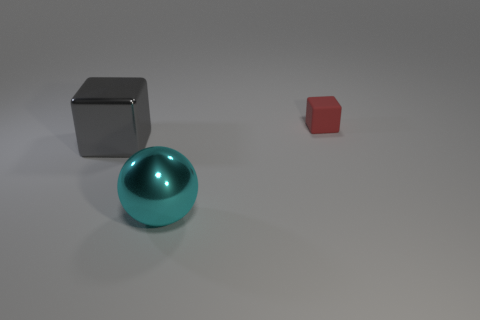Is there anything else that has the same shape as the cyan metal thing?
Provide a succinct answer. No. The other gray metal thing that is the same shape as the tiny object is what size?
Give a very brief answer. Large. Is there any other thing that is the same size as the red thing?
Keep it short and to the point. No. There is a big shiny sphere; are there any big things behind it?
Keep it short and to the point. Yes. Is the color of the metallic thing that is in front of the big gray metallic thing the same as the block on the right side of the ball?
Your answer should be very brief. No. Are there any other small things that have the same shape as the gray object?
Provide a succinct answer. Yes. What number of other things are the same color as the tiny object?
Your answer should be very brief. 0. There is a matte block to the right of the metallic thing that is on the left side of the large thing in front of the large gray block; what color is it?
Make the answer very short. Red. Are there the same number of objects behind the big sphere and large blocks?
Your answer should be compact. No. There is a shiny object on the right side of the metallic cube; is its size the same as the tiny red thing?
Offer a terse response. No. 